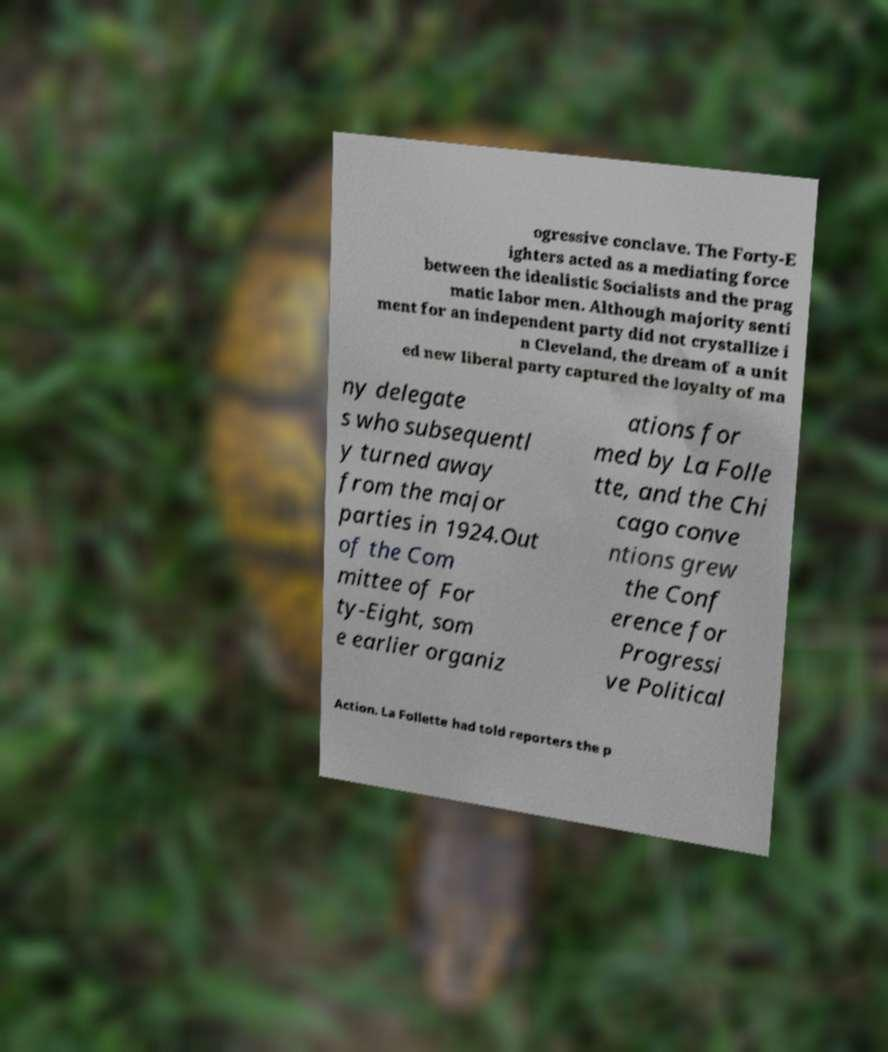Can you accurately transcribe the text from the provided image for me? ogressive conclave. The Forty-E ighters acted as a mediating force between the idealistic Socialists and the prag matic labor men. Although majority senti ment for an independent party did not crystallize i n Cleveland, the dream of a unit ed new liberal party captured the loyalty of ma ny delegate s who subsequentl y turned away from the major parties in 1924.Out of the Com mittee of For ty-Eight, som e earlier organiz ations for med by La Folle tte, and the Chi cago conve ntions grew the Conf erence for Progressi ve Political Action. La Follette had told reporters the p 